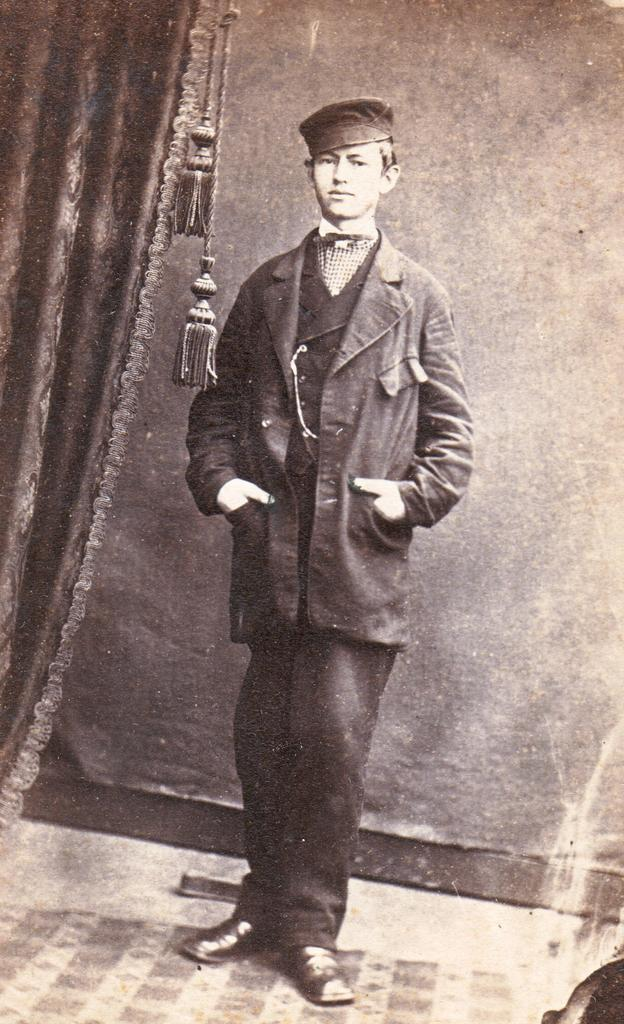Who is present in the image? There is a man in the image. What is the man doing in the image? The man is standing in the image. What type of clothing is the man wearing? The man is wearing a jacket, a cap, a pant, and shoes. What can be seen on the left side of the image? There is a curtain on the left side of the image. What type of dog is sitting next to the man in the image? There is no dog present in the image. Can you see any smoke coming from the man's shoes in the image? There is no smoke visible in the image. 